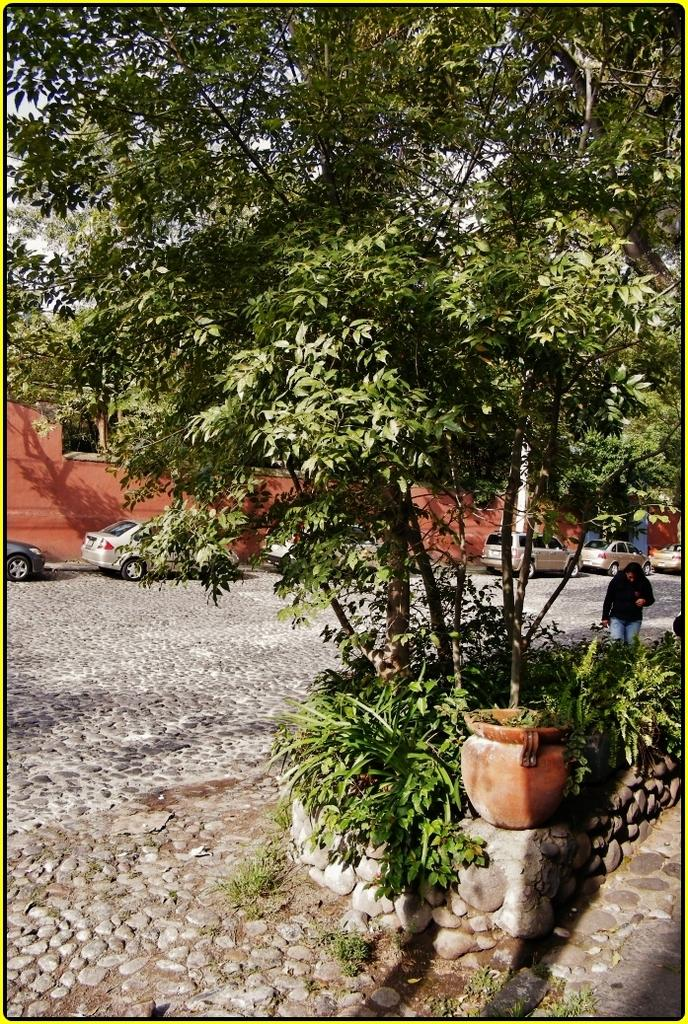What is located in the foreground of the picture? There are plants and a tree in the foreground of the picture. Can you describe the person in the picture? There is a person on the right side of the picture. What can be seen in the background of the picture? There are cars and a building in the background of the picture. What type of frame is surrounding the person in the picture? There is no frame surrounding the person in the picture. Can you tell me how many boats are docked at the harbor in the image? There is no harbor or boats present in the image. 